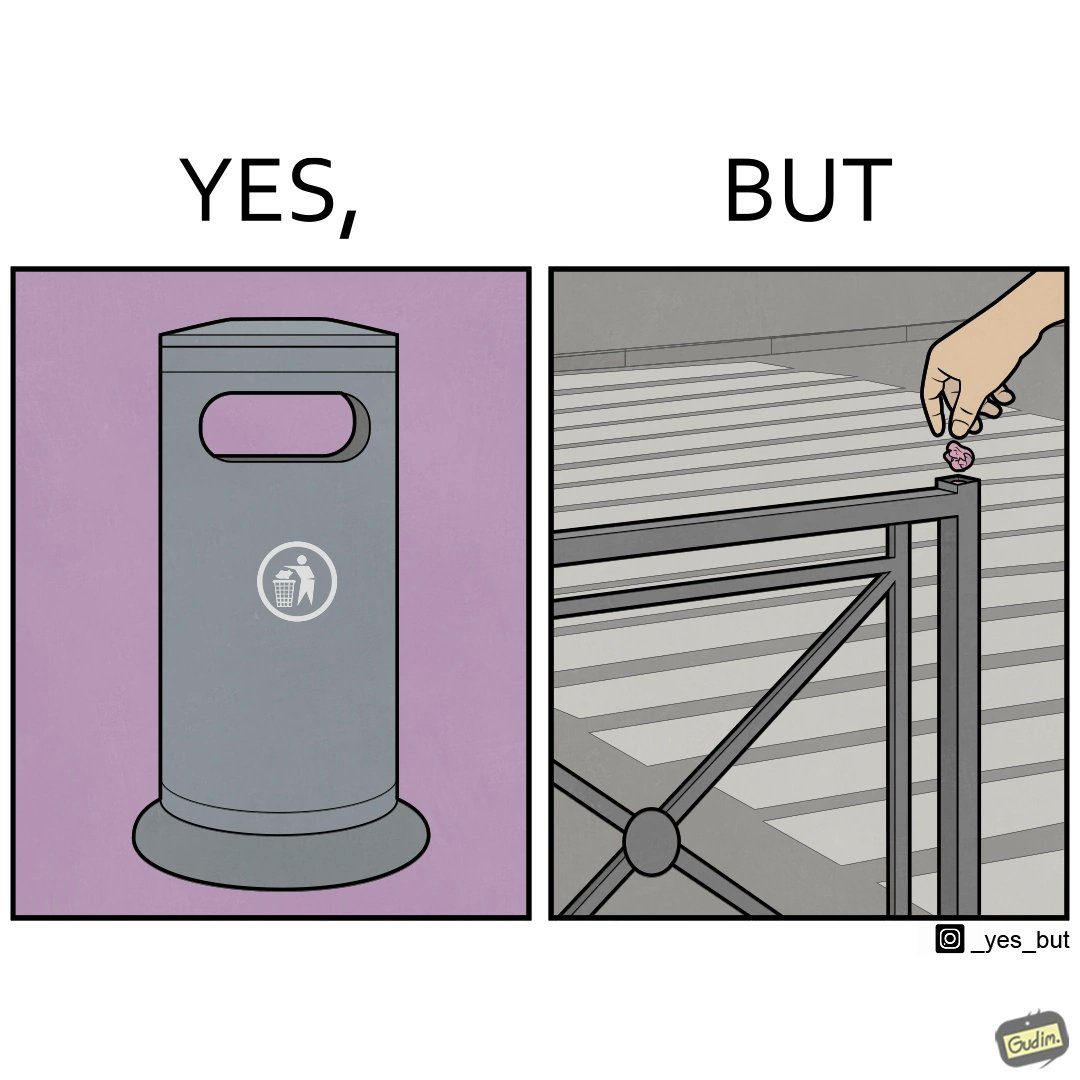Compare the left and right sides of this image. In the left part of the image: It is a garbage bin In the right part of the image: It is a human hand sticking chewing gum on public property 